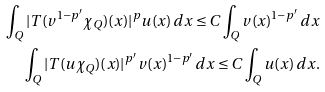<formula> <loc_0><loc_0><loc_500><loc_500>\int _ { Q } | T ( v ^ { 1 - p ^ { \prime } } \chi _ { Q } ) ( x ) | ^ { p } u ( x ) \, d x \leq C \int _ { Q } v ( x ) ^ { 1 - p ^ { \prime } } \, d x \\ \int _ { Q } | T ( u \chi _ { Q } ) ( x ) | ^ { p ^ { \prime } } v ( x ) ^ { 1 - p ^ { \prime } } \, d x \leq C \int _ { Q } u ( x ) \, d x .</formula> 